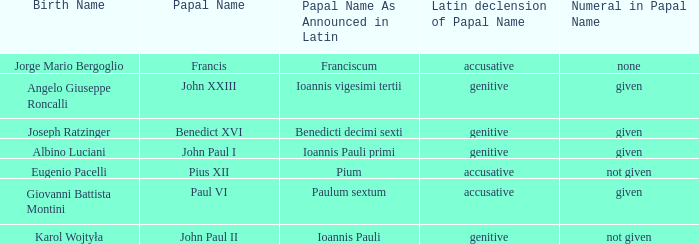For the pope born Eugenio Pacelli, what is the declension of his papal name? Accusative. 